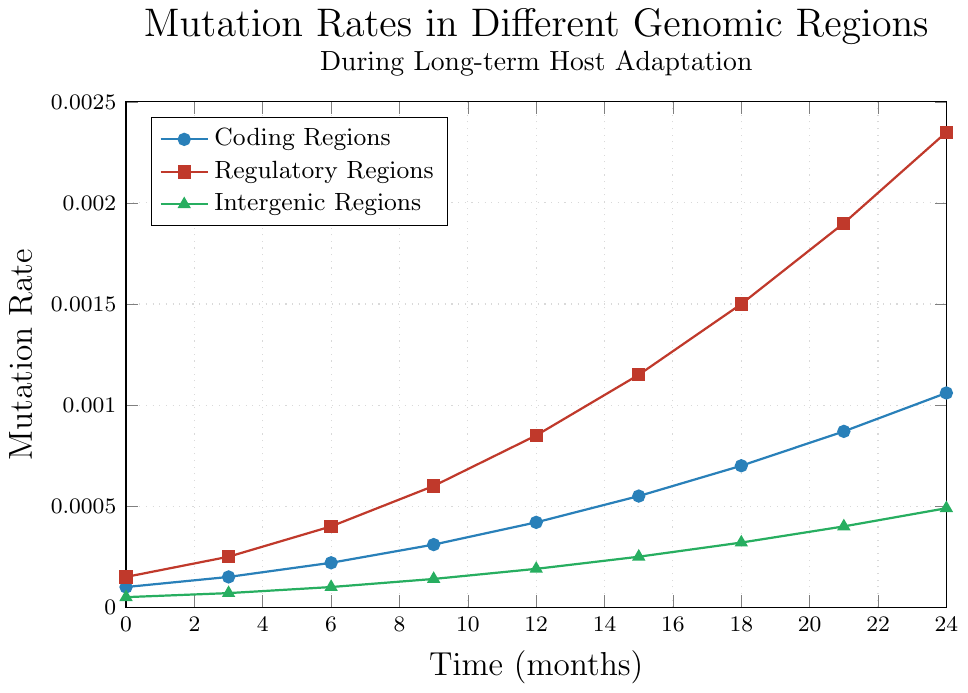What is the mutation rate for coding regions at 15 months? To find the mutation rate for coding regions at 15 months, look at the point marked for coding regions (blue line) corresponding to the 15th month on the x-axis. The mutation rate is 0.00055.
Answer: 0.00055 Which genomic region has the highest mutation rate at 24 months? Compare the mutation rates of coding, regulatory, and intergenic regions at the 24th month on the x-axis. The regulatory regions (red line) have the highest mutation rate of 0.00235 at 24 months.
Answer: Regulatory regions By how much does the mutation rate in the regulatory regions increase between 6 and 18 months? Calculate the difference in mutation rates for regulatory regions (red line) at 18 months and 6 months. At 18 months, the rate is 0.00150 and at 6 months, it is 0.00040. The increase is 0.00150 - 0.00040 = 0.00110.
Answer: 0.00110 Which genomic region shows the steepest increase in mutation rate over time? Compare the slopes of the lines representing coding, regulatory, and intergenic regions. The regulatory regions (red line) show the steepest increase in mutation rate over time.
Answer: Regulatory regions At what time point do the mutation rates of coding regions and intergenic regions intersect? Observe the lines for coding regions (blue) and intergenic regions (green) to identify any intersections. The two lines do not intersect; hence, they do not have equal mutation rates at any time point.
Answer: They do not intersect What is the overall trend in mutation rates for intergenic regions from 0 to 24 months? Observe the green line representing intergenic regions. The mutation rate starts from 0.00005 and steadily increases to 0.00049 over the 24 months, showing a consistent upward trend.
Answer: Upward trend By how much does the mutation rate for coding regions change from 3 months to 21 months? Find the difference in mutation rates for coding regions (blue line) at 21 months and 3 months. At 21 months, the rate is 0.00087 and at 3 months, it is 0.00015. The change is 0.00087 - 0.00015 = 0.00072.
Answer: 0.00072 What is the rate of change in mutation rate for regulatory regions between 12 and 15 months? Calculate the rate of change by finding the difference between mutation rates at 15 months and 12 months, then divide by the time difference. The mutation rates are 0.00115 at 15 months and 0.00085 at 12 months. The rate of change is (0.00115 - 0.00085) / (15 - 12) = 0.00030 / 3 = 0.00010 per month.
Answer: 0.00010 per month 